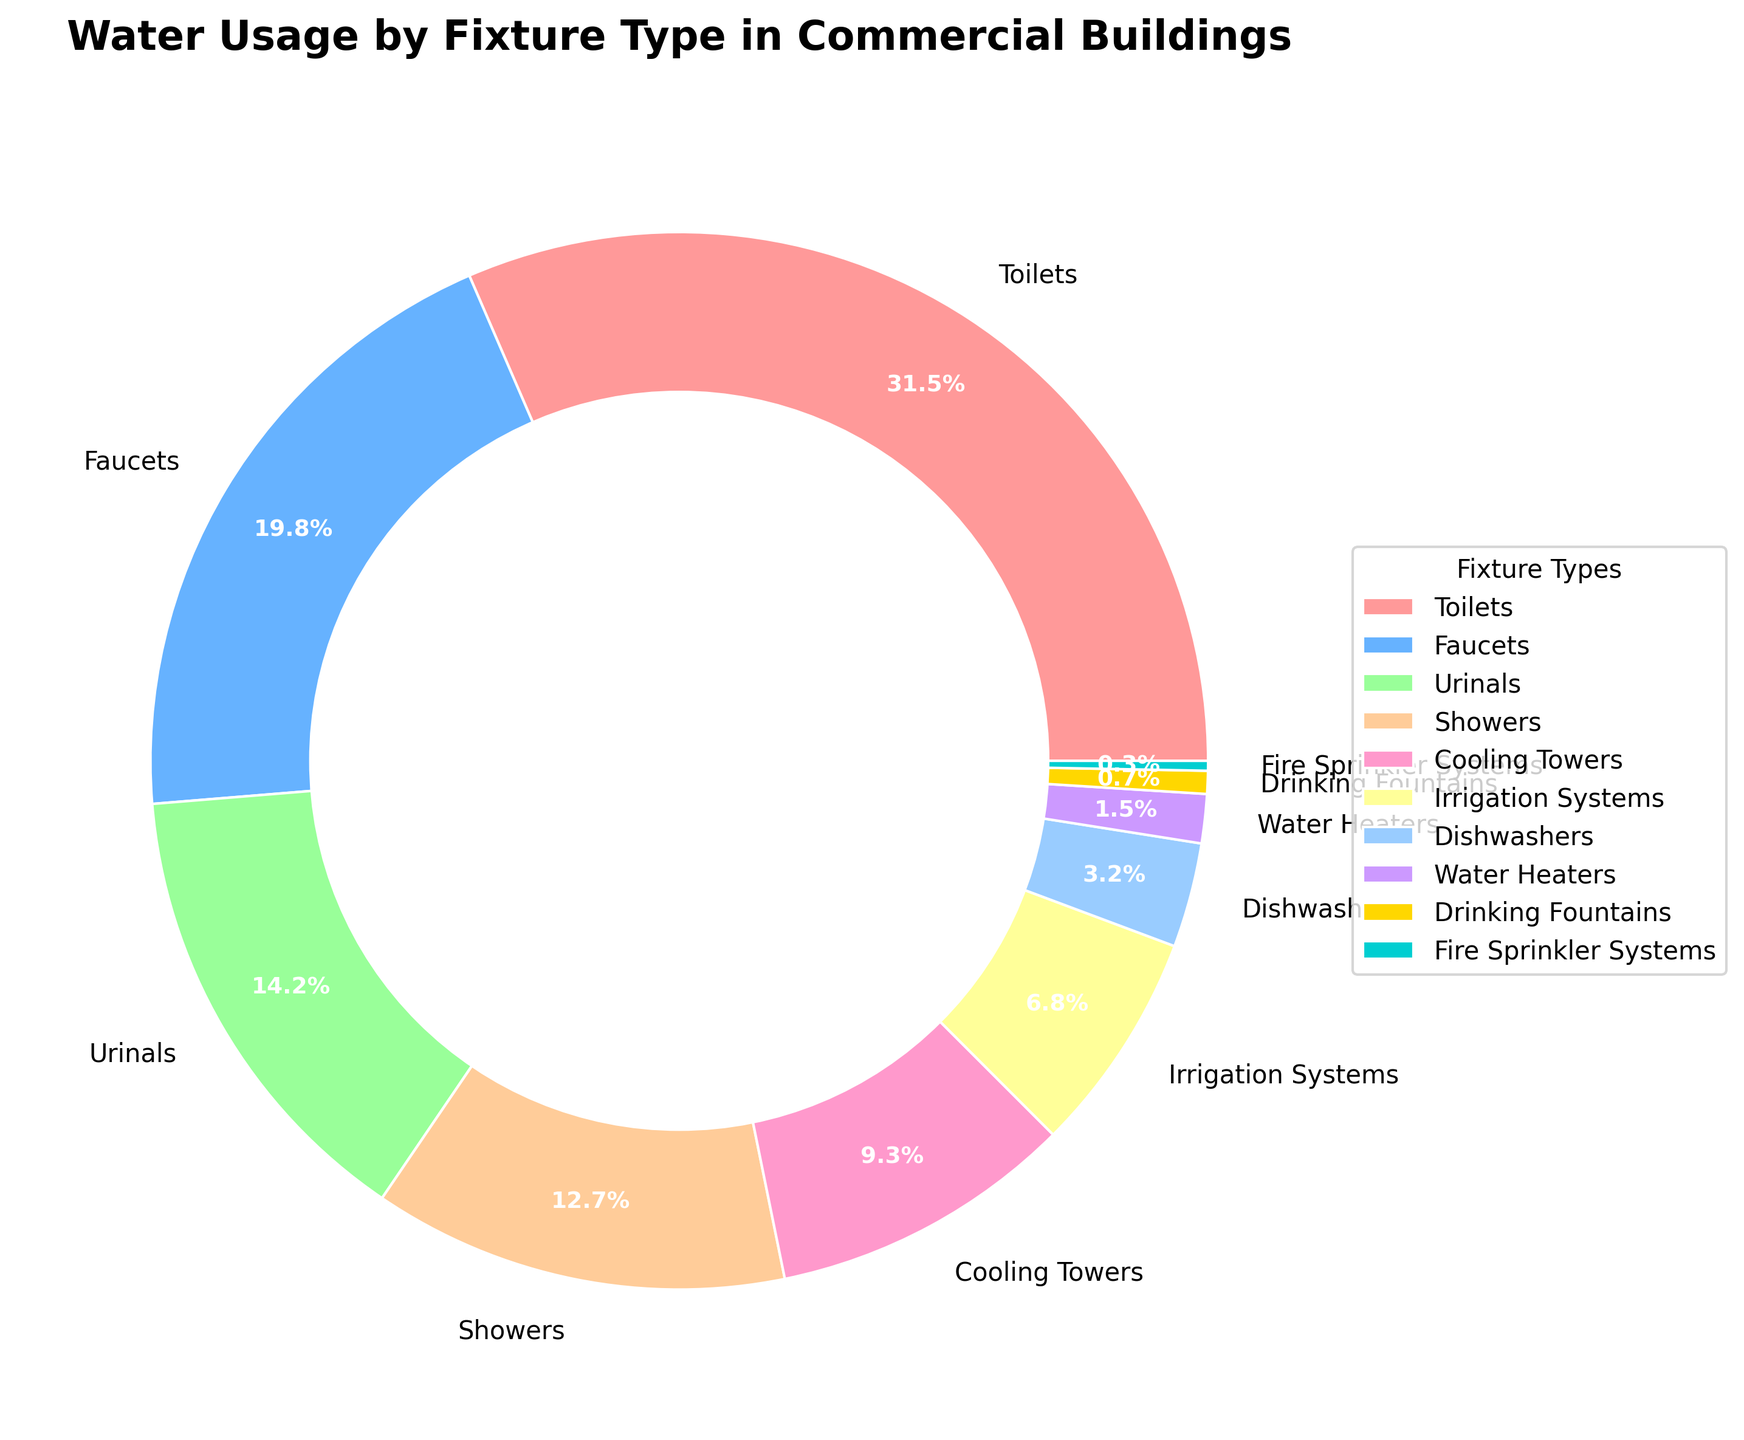What are the top three fixture types in terms of water usage percentage? To determine the top three fixture types, we look at the usage percentages provided. The three highest percentages are 31.5% (Toilets), 19.8% (Faucets), and 14.2% (Urinals).
Answer: Toilets, Faucets, and Urinals How much more water is used by toilets compared to showers? To find out the difference, subtract the percentage of showers from the percentage of toilets. Specifically, 31.5% (Toilets) - 12.7% (Showers) = 18.8%.
Answer: 18.8% Which fixture type uses the least amount of water? Looking at the provided data, the fixture type with the smallest usage percentage is Fire Sprinkler Systems at 0.3%.
Answer: Fire Sprinkler Systems What is the combined water usage percentage of faucets and urinals? To find the combined usage, add the percentage of faucets and urinals together. Specifically, 19.8% (Faucets) + 14.2% (Urinals) = 34%.
Answer: 34% How much more water is used by cooling towers compared to irrigation systems? To determine the difference, subtract the percentage of irrigation systems from the percentage of cooling towers. Specifically, 9.3% (Cooling Towers) - 6.8% (Irrigation Systems) = 2.5%.
Answer: 2.5% What percentage of water usage is accounted for by dishwashers, water heaters, and drinking fountains together? To find the total percentage, add the individual percentages together: 3.2% (Dishwashers) + 1.5% (Water Heaters) + 0.7% (Drinking Fountains) = 5.4%.
Answer: 5.4% Are showers using more water than cooling towers? Comparing the percentages, showers have a usage of 12.7% and cooling towers have 9.3%, thus showers use more water.
Answer: Yes Which fixture type has the highest percentage of water usage? By examining the data, toilets have the highest percentage of water usage at 31.5%.
Answer: Toilets What is the difference in water usage between urinals and drinking fountains? To find the difference, subtract the percentage of drinking fountains from the percentage of urinals. Specifically, 14.2% (Urinals) - 0.7% (Drinking Fountains) = 13.5%.
Answer: 13.5% 